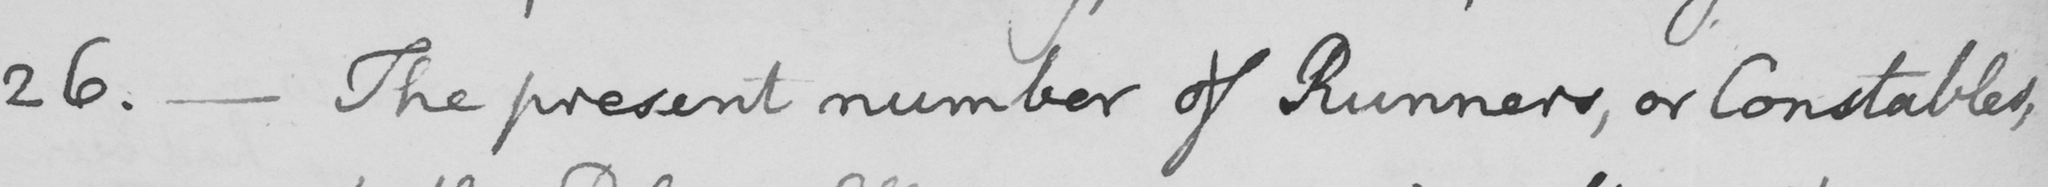What is written in this line of handwriting? 26. _ The present number of Runners, or Constables, 